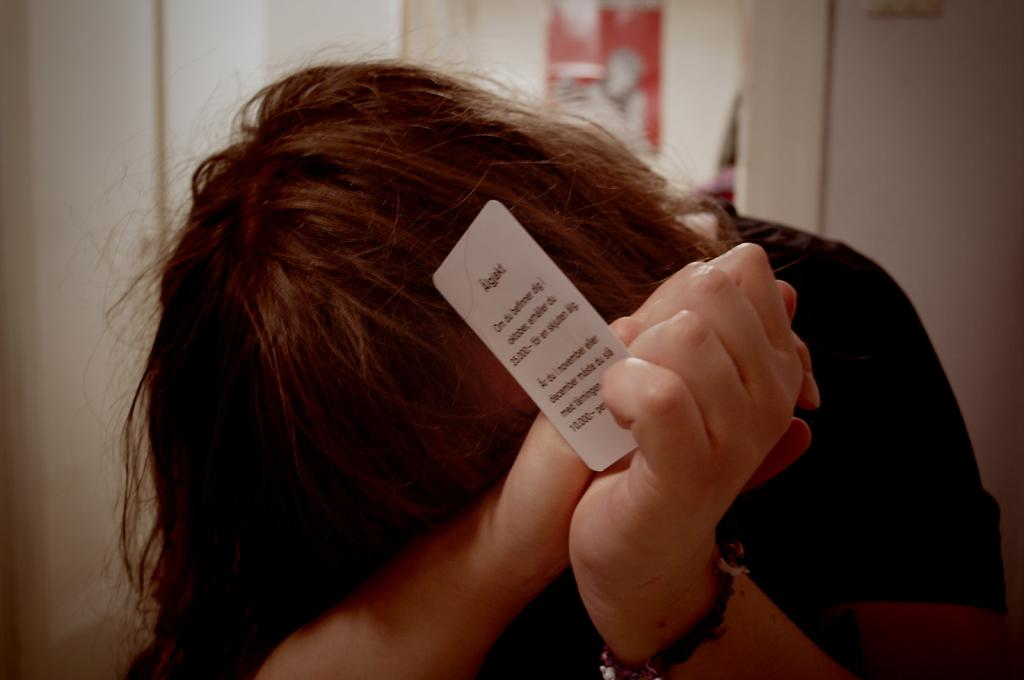What is the main subject of the image? There is a person in the image. What is the person holding in the image? The person is holding a card with text written on it. What else can be seen in the image besides the person? There is a poster visible in the image. What type of background is present in the image? There is a wall in the image. What type of country is depicted on the poster in the image? There is no country depicted on the poster in the image; it is not mentioned in the provided facts. Can you describe the zephyr blowing through the cave in the image? There is no zephyr or cave present in the image; these elements are not mentioned in the provided facts. 